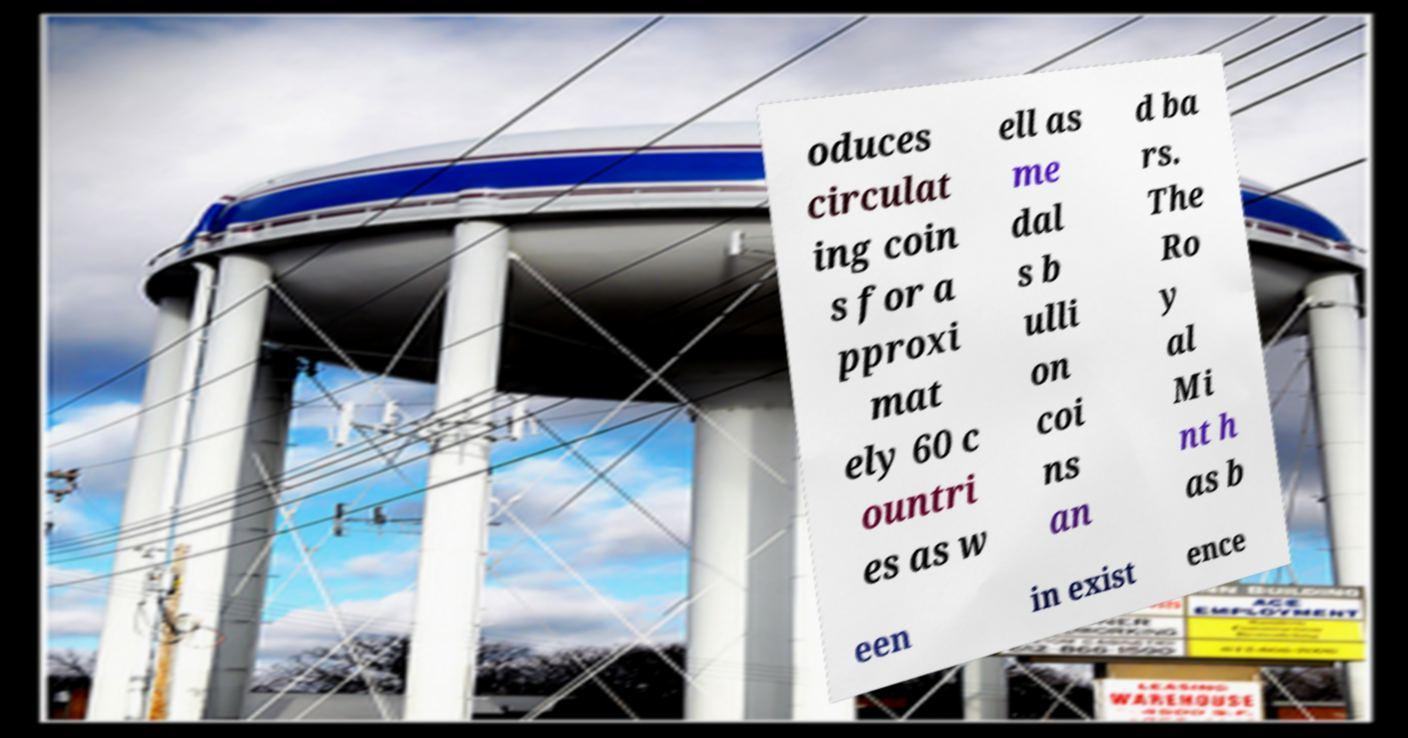What messages or text are displayed in this image? I need them in a readable, typed format. oduces circulat ing coin s for a pproxi mat ely 60 c ountri es as w ell as me dal s b ulli on coi ns an d ba rs. The Ro y al Mi nt h as b een in exist ence 